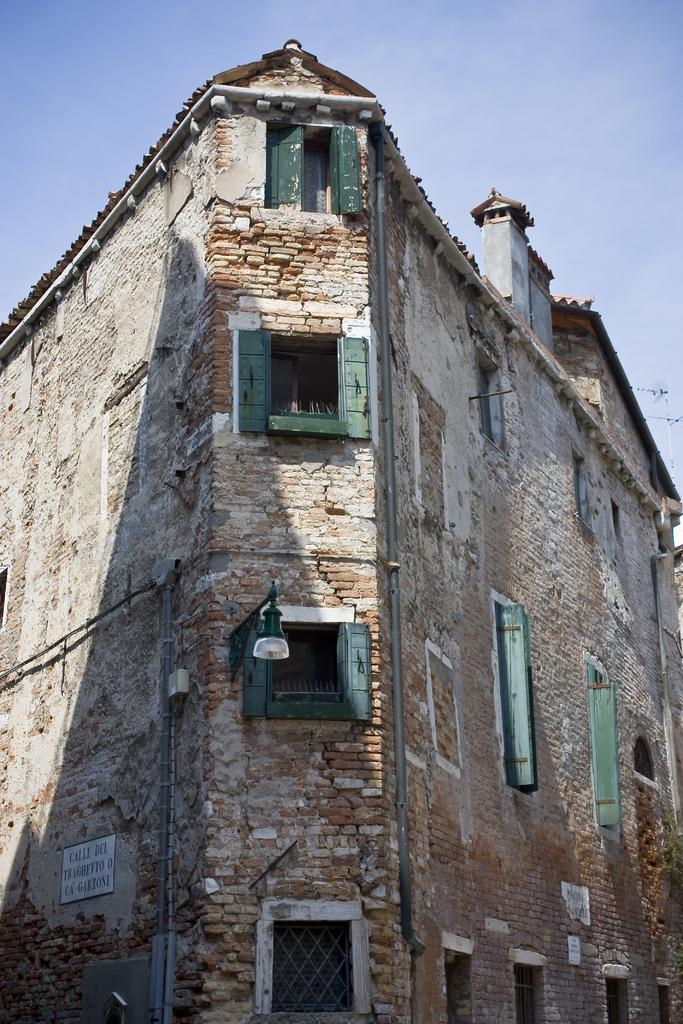What type of structure is present in the image? There is a building in the image. What feature can be seen on the building? The building has windows. What else is visible in the image besides the building? There is a street light pole in the image. What is the condition of the sky in the image? The sky is clear in the image. Can you tell me how many legs the building has in the image? Buildings do not have legs; they are stationary structures. The question is not applicable to the image. 